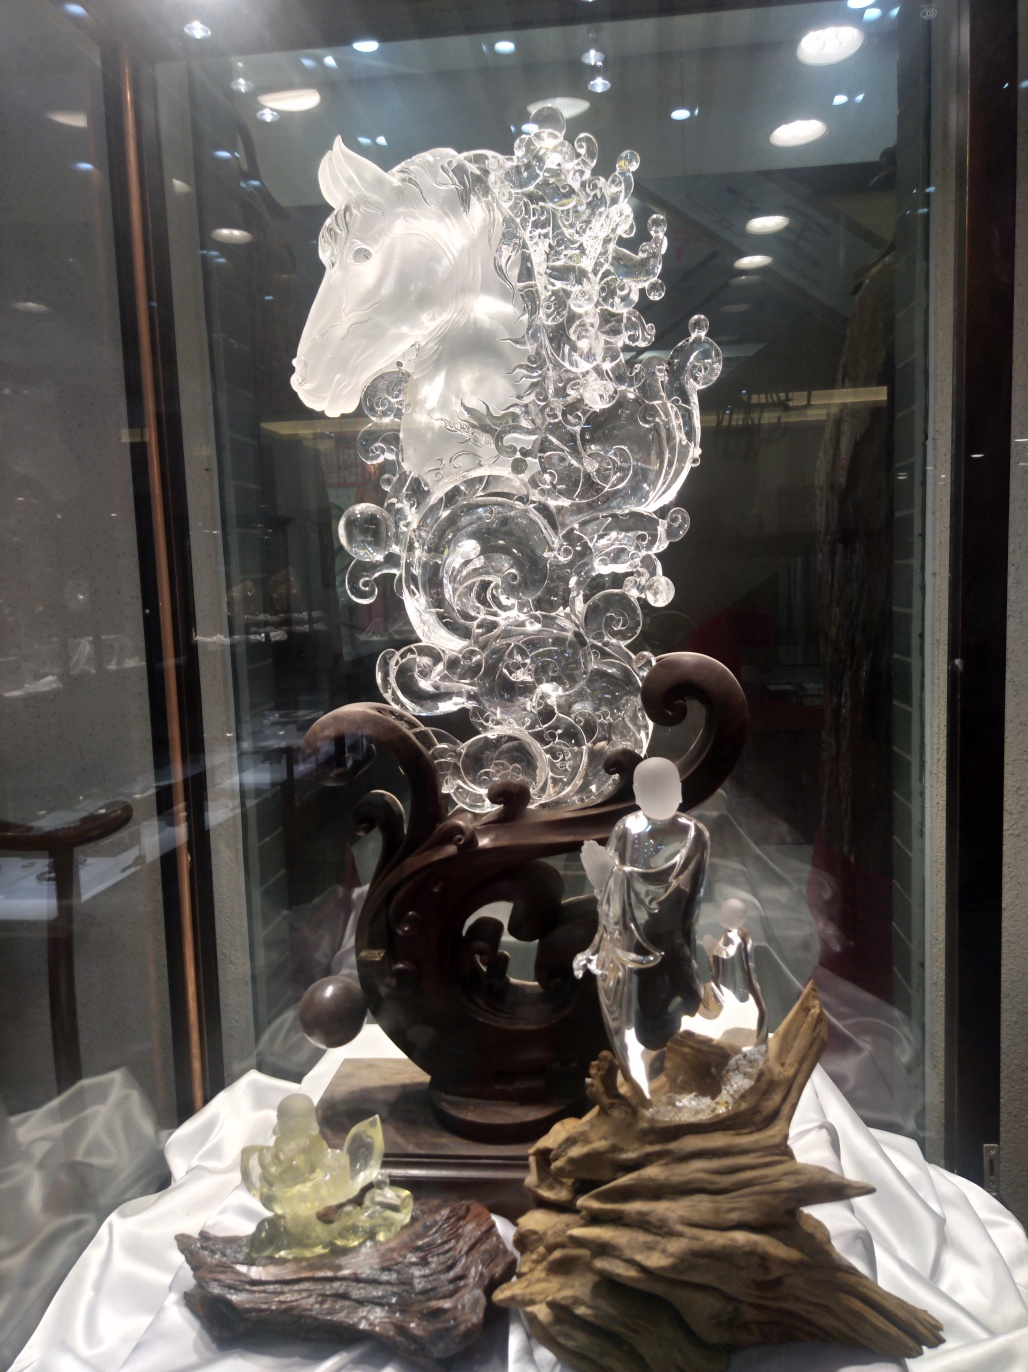What can be said about the quality of this image?
A. Mediocre
B. Terrible
C. Good
Answer with the option's letter from the given choices directly.
 C. 